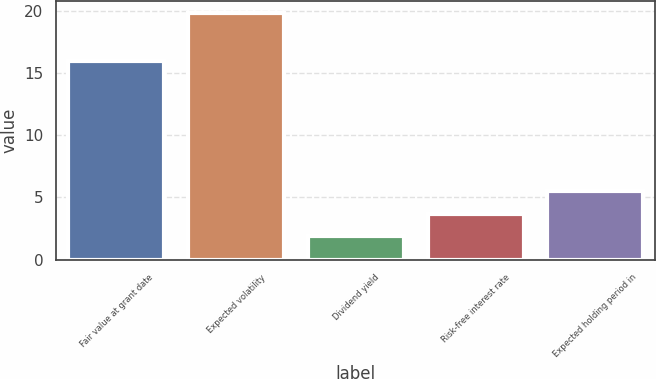Convert chart. <chart><loc_0><loc_0><loc_500><loc_500><bar_chart><fcel>Fair value at grant date<fcel>Expected volatility<fcel>Dividend yield<fcel>Risk-free interest rate<fcel>Expected holding period in<nl><fcel>15.98<fcel>19.8<fcel>1.9<fcel>3.69<fcel>5.48<nl></chart> 